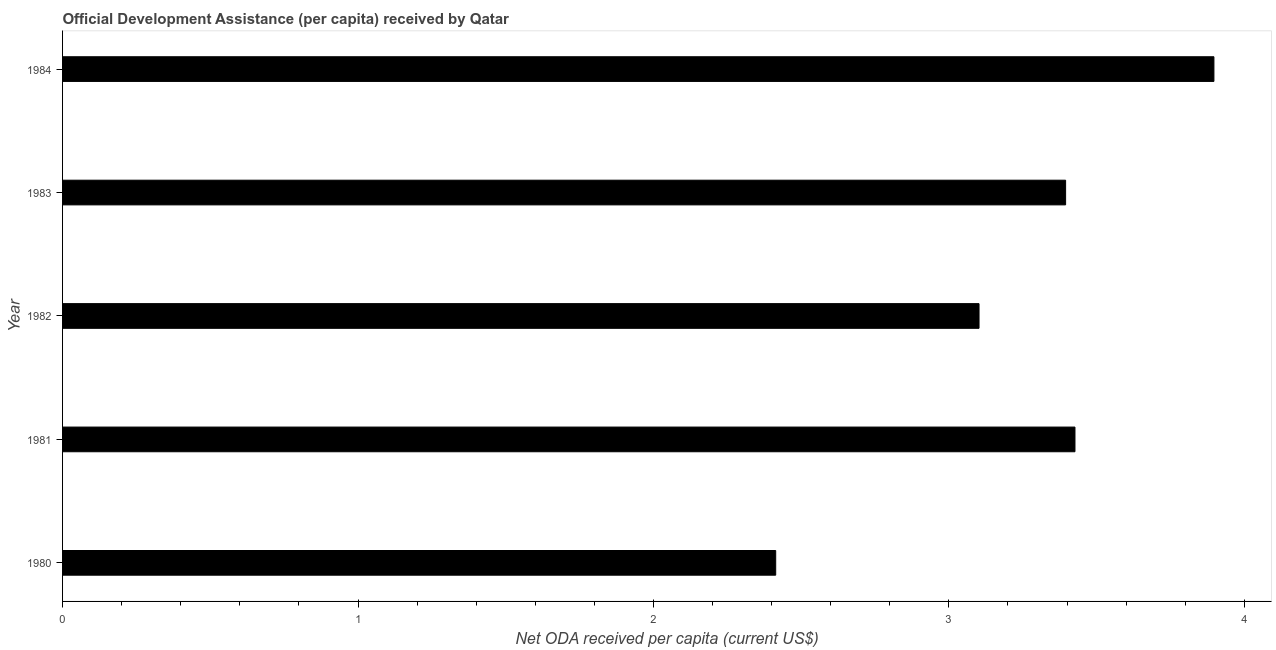Does the graph contain any zero values?
Provide a short and direct response. No. What is the title of the graph?
Make the answer very short. Official Development Assistance (per capita) received by Qatar. What is the label or title of the X-axis?
Your answer should be very brief. Net ODA received per capita (current US$). What is the net oda received per capita in 1984?
Ensure brevity in your answer.  3.9. Across all years, what is the maximum net oda received per capita?
Ensure brevity in your answer.  3.9. Across all years, what is the minimum net oda received per capita?
Your answer should be very brief. 2.41. What is the sum of the net oda received per capita?
Your answer should be very brief. 16.23. What is the difference between the net oda received per capita in 1980 and 1982?
Make the answer very short. -0.69. What is the average net oda received per capita per year?
Provide a succinct answer. 3.25. What is the median net oda received per capita?
Provide a succinct answer. 3.4. In how many years, is the net oda received per capita greater than 1.8 US$?
Keep it short and to the point. 5. What is the ratio of the net oda received per capita in 1980 to that in 1982?
Your response must be concise. 0.78. Is the net oda received per capita in 1980 less than that in 1984?
Keep it short and to the point. Yes. What is the difference between the highest and the second highest net oda received per capita?
Your answer should be very brief. 0.47. Is the sum of the net oda received per capita in 1980 and 1983 greater than the maximum net oda received per capita across all years?
Keep it short and to the point. Yes. What is the difference between the highest and the lowest net oda received per capita?
Give a very brief answer. 1.48. Are all the bars in the graph horizontal?
Your answer should be very brief. Yes. What is the difference between two consecutive major ticks on the X-axis?
Your answer should be very brief. 1. What is the Net ODA received per capita (current US$) in 1980?
Your answer should be compact. 2.41. What is the Net ODA received per capita (current US$) of 1981?
Your answer should be very brief. 3.43. What is the Net ODA received per capita (current US$) of 1982?
Offer a very short reply. 3.1. What is the Net ODA received per capita (current US$) of 1983?
Make the answer very short. 3.4. What is the Net ODA received per capita (current US$) in 1984?
Ensure brevity in your answer.  3.9. What is the difference between the Net ODA received per capita (current US$) in 1980 and 1981?
Your answer should be very brief. -1.01. What is the difference between the Net ODA received per capita (current US$) in 1980 and 1982?
Give a very brief answer. -0.69. What is the difference between the Net ODA received per capita (current US$) in 1980 and 1983?
Provide a succinct answer. -0.98. What is the difference between the Net ODA received per capita (current US$) in 1980 and 1984?
Make the answer very short. -1.48. What is the difference between the Net ODA received per capita (current US$) in 1981 and 1982?
Offer a terse response. 0.32. What is the difference between the Net ODA received per capita (current US$) in 1981 and 1983?
Make the answer very short. 0.03. What is the difference between the Net ODA received per capita (current US$) in 1981 and 1984?
Your response must be concise. -0.47. What is the difference between the Net ODA received per capita (current US$) in 1982 and 1983?
Your answer should be very brief. -0.29. What is the difference between the Net ODA received per capita (current US$) in 1982 and 1984?
Your answer should be compact. -0.8. What is the difference between the Net ODA received per capita (current US$) in 1983 and 1984?
Provide a short and direct response. -0.5. What is the ratio of the Net ODA received per capita (current US$) in 1980 to that in 1981?
Your response must be concise. 0.7. What is the ratio of the Net ODA received per capita (current US$) in 1980 to that in 1982?
Make the answer very short. 0.78. What is the ratio of the Net ODA received per capita (current US$) in 1980 to that in 1983?
Give a very brief answer. 0.71. What is the ratio of the Net ODA received per capita (current US$) in 1980 to that in 1984?
Ensure brevity in your answer.  0.62. What is the ratio of the Net ODA received per capita (current US$) in 1981 to that in 1982?
Keep it short and to the point. 1.1. What is the ratio of the Net ODA received per capita (current US$) in 1981 to that in 1983?
Your answer should be very brief. 1.01. What is the ratio of the Net ODA received per capita (current US$) in 1981 to that in 1984?
Your response must be concise. 0.88. What is the ratio of the Net ODA received per capita (current US$) in 1982 to that in 1983?
Your answer should be compact. 0.91. What is the ratio of the Net ODA received per capita (current US$) in 1982 to that in 1984?
Provide a succinct answer. 0.8. What is the ratio of the Net ODA received per capita (current US$) in 1983 to that in 1984?
Offer a terse response. 0.87. 